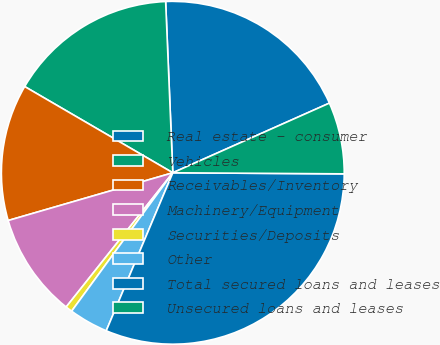Convert chart to OTSL. <chart><loc_0><loc_0><loc_500><loc_500><pie_chart><fcel>Real estate - consumer<fcel>Vehicles<fcel>Receivables/Inventory<fcel>Machinery/Equipment<fcel>Securities/Deposits<fcel>Other<fcel>Total secured loans and leases<fcel>Unsecured loans and leases<nl><fcel>19.0%<fcel>15.94%<fcel>12.88%<fcel>9.82%<fcel>0.64%<fcel>3.7%<fcel>31.24%<fcel>6.76%<nl></chart> 